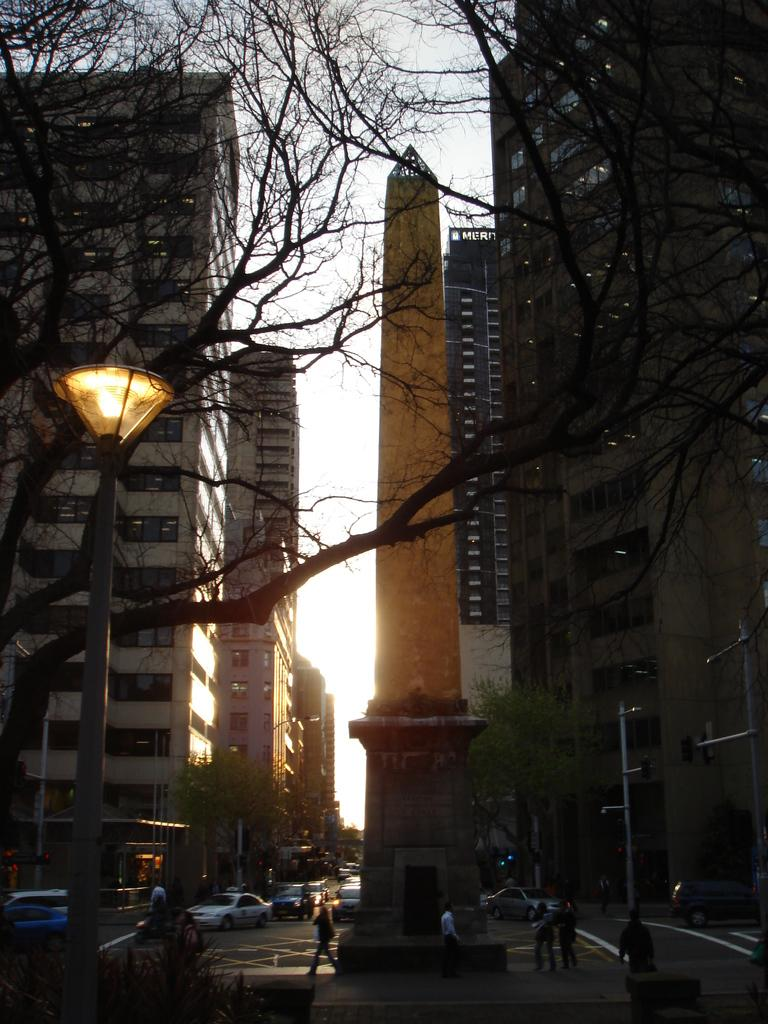What are the people in the image doing? The people in the image are walking. What else can be seen in the image besides people? There are vehicles, light poles, trees, and buildings in the background visible in the image. What is the color of the sky in the image? The sky is white in color. How many ladybugs can be seen flying in the air in the image? There are no ladybugs present in the image; it features people walking, vehicles, light poles, trees, buildings, and a white sky. What is the level of the buildings in the image? The provided facts do not mention the level or height of the buildings in the image. 